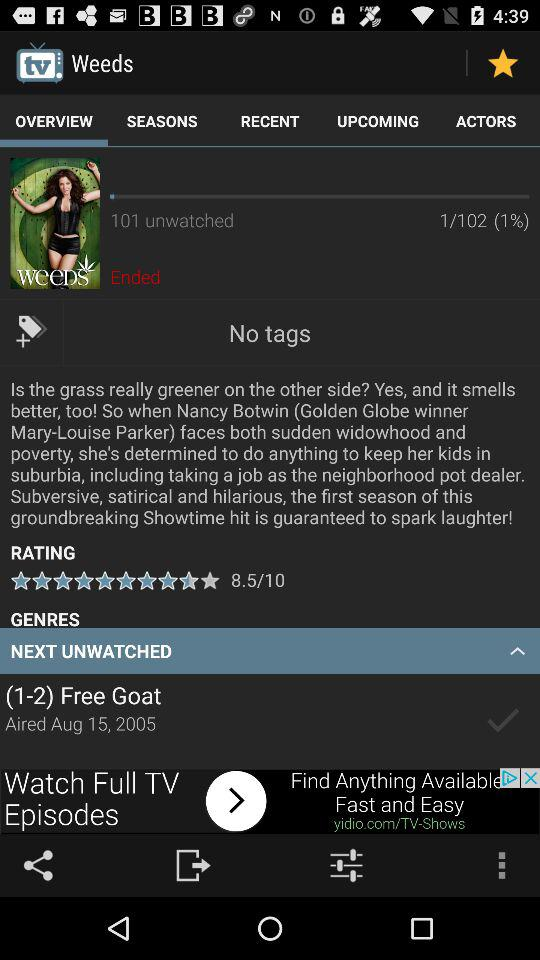What is the date? The date is August 15, 2005. 